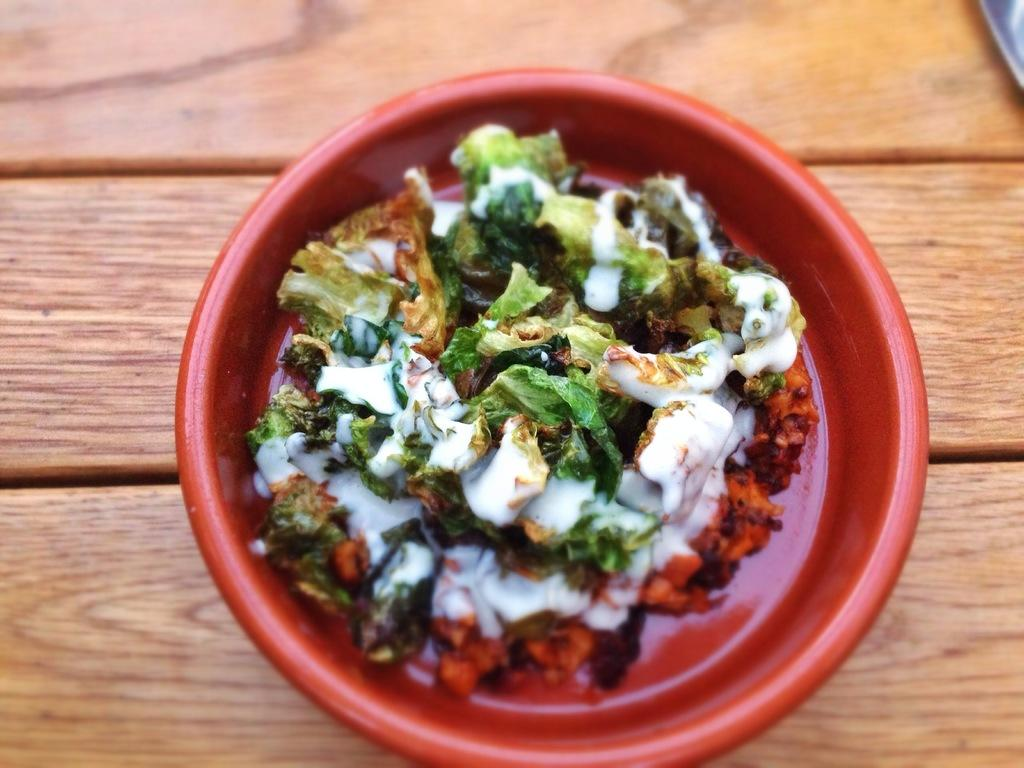What type of food item can be seen in the image? The specific type of food item is not mentioned, but there is a food item visible in the image. How is the food item contained in the image? The food item is in a red color bowl. What is the surface beneath the red color bowl? The red color bowl is on a wooden surface. Can you see a flock of birds flying over the wooden surface in the image? No, there is no mention of birds or a flock in the image; it only features a food item in a red color bowl on a wooden surface. 